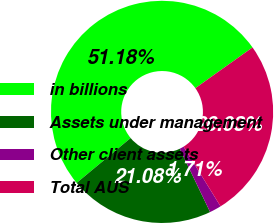Convert chart. <chart><loc_0><loc_0><loc_500><loc_500><pie_chart><fcel>in billions<fcel>Assets under management<fcel>Other client assets<fcel>Total AUS<nl><fcel>51.19%<fcel>21.08%<fcel>1.71%<fcel>26.03%<nl></chart> 